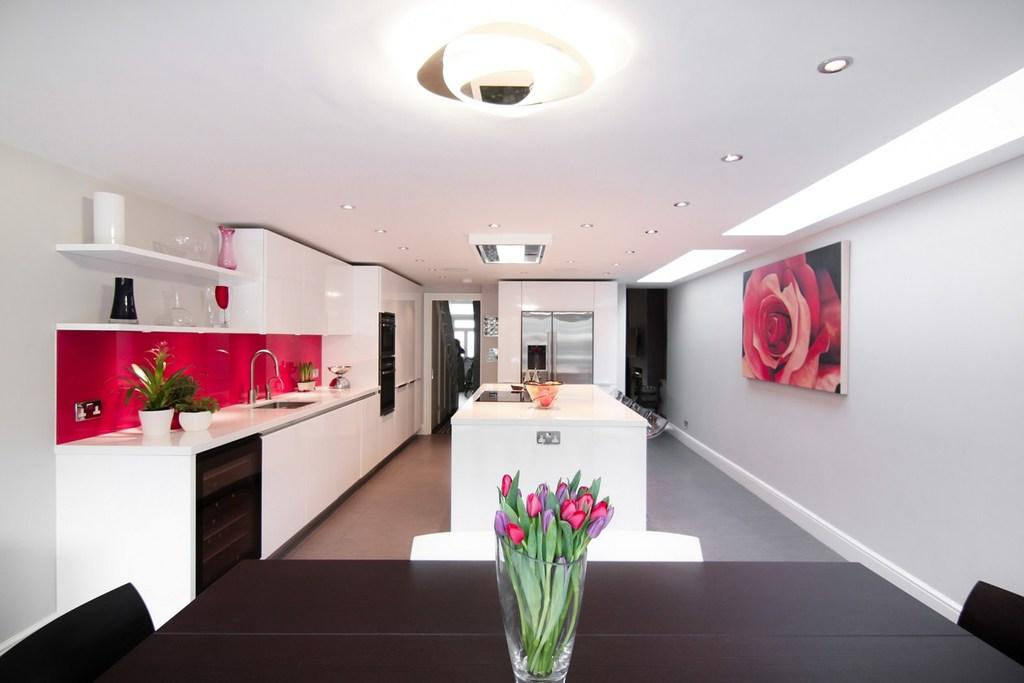What is hanging on the wall in the image? There is a frame on the wall in the image. What type of vegetation can be seen in the image? There are plants visible in the image. Can you describe a feature of the room or space in the image? There is a sink in the image. How many cows are grazing in the image? There are no cows present in the image. What type of attraction is featured in the image? There is no attraction present in the image; it only contains a frame on the wall, plants, and a sink. 